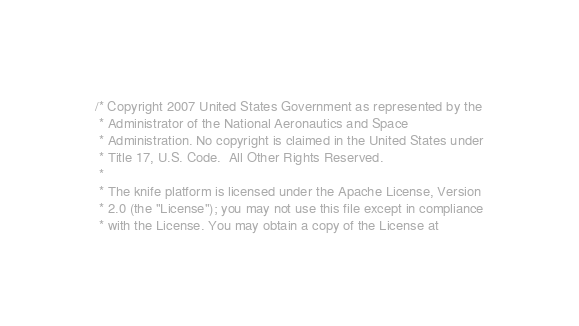<code> <loc_0><loc_0><loc_500><loc_500><_C_>
/* Copyright 2007 United States Government as represented by the
 * Administrator of the National Aeronautics and Space
 * Administration. No copyright is claimed in the United States under
 * Title 17, U.S. Code.  All Other Rights Reserved.
 *
 * The knife platform is licensed under the Apache License, Version
 * 2.0 (the "License"); you may not use this file except in compliance
 * with the License. You may obtain a copy of the License at</code> 